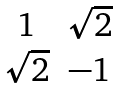Convert formula to latex. <formula><loc_0><loc_0><loc_500><loc_500>\begin{matrix} 1 & \sqrt { 2 } \\ \sqrt { 2 } & - 1 \end{matrix}</formula> 